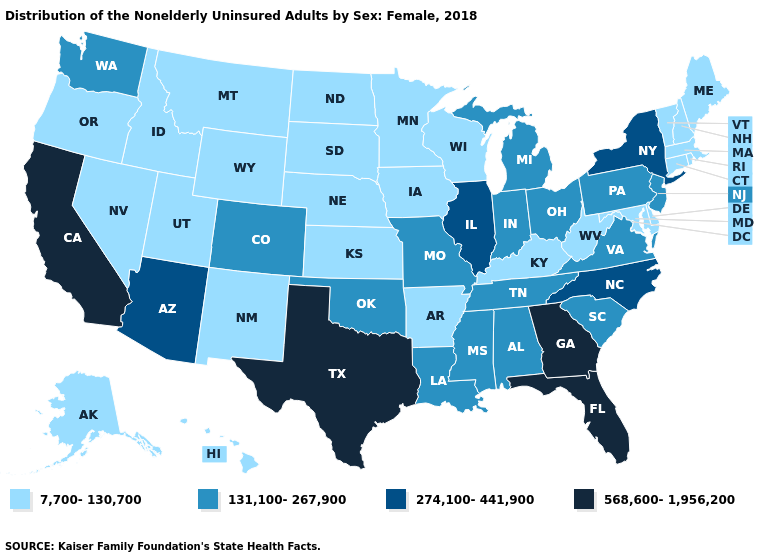Does Colorado have a lower value than New York?
Answer briefly. Yes. Does the first symbol in the legend represent the smallest category?
Concise answer only. Yes. What is the value of North Carolina?
Be succinct. 274,100-441,900. What is the value of Maine?
Concise answer only. 7,700-130,700. What is the lowest value in the MidWest?
Keep it brief. 7,700-130,700. What is the highest value in states that border Massachusetts?
Concise answer only. 274,100-441,900. Name the states that have a value in the range 568,600-1,956,200?
Keep it brief. California, Florida, Georgia, Texas. What is the value of Oklahoma?
Answer briefly. 131,100-267,900. Does California have the highest value in the West?
Short answer required. Yes. Does California have a lower value than Alaska?
Write a very short answer. No. Does Pennsylvania have the same value as Idaho?
Quick response, please. No. Name the states that have a value in the range 131,100-267,900?
Write a very short answer. Alabama, Colorado, Indiana, Louisiana, Michigan, Mississippi, Missouri, New Jersey, Ohio, Oklahoma, Pennsylvania, South Carolina, Tennessee, Virginia, Washington. Among the states that border Utah , which have the highest value?
Concise answer only. Arizona. Name the states that have a value in the range 131,100-267,900?
Write a very short answer. Alabama, Colorado, Indiana, Louisiana, Michigan, Mississippi, Missouri, New Jersey, Ohio, Oklahoma, Pennsylvania, South Carolina, Tennessee, Virginia, Washington. What is the highest value in the West ?
Short answer required. 568,600-1,956,200. 